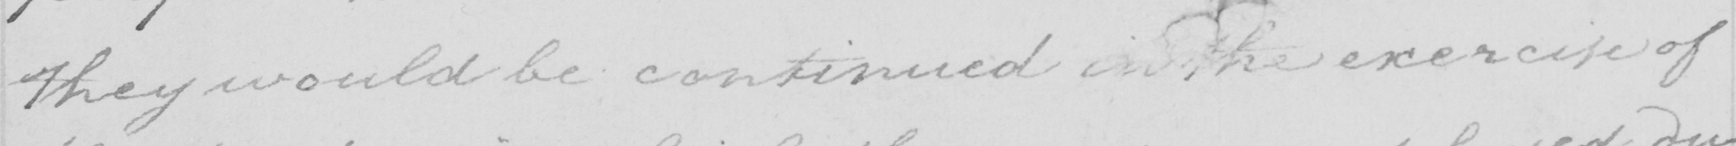What text is written in this handwritten line? they would be continued in the exercise of 